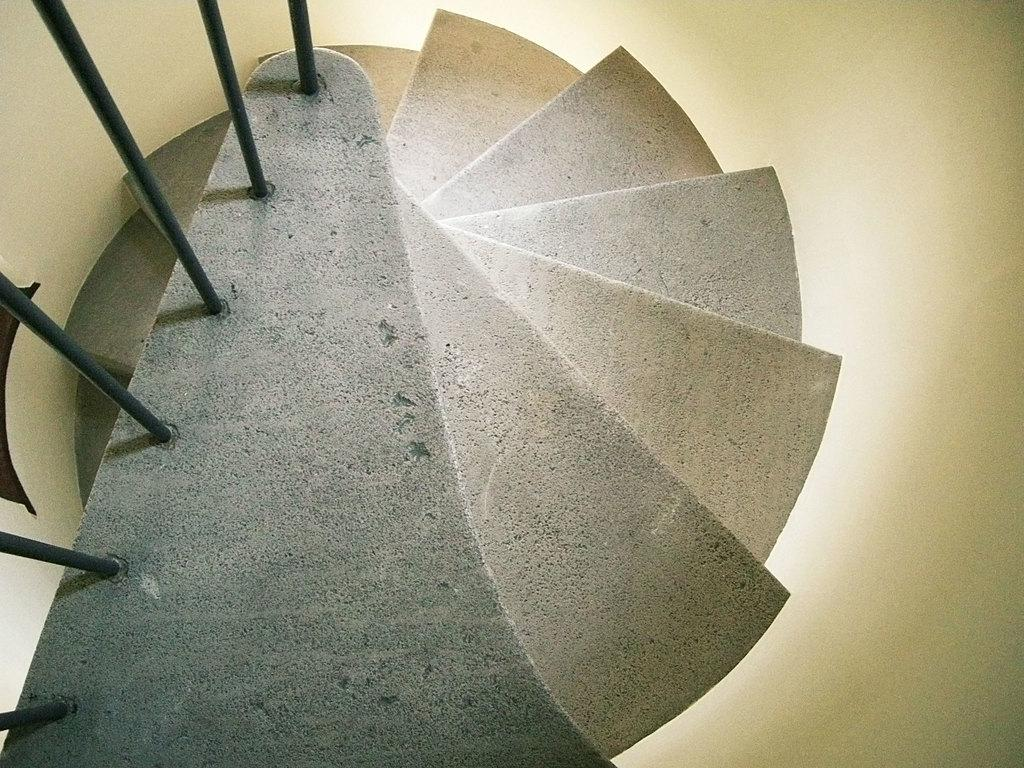What type of architectural feature is present in the image? There are steps in the image. Are there any other objects near the steps? Yes, there are iron rods near the steps in the image. How does the breath of the person affect the iron rods in the image? There is no person present in the image, and therefore no breath to affect the iron rods. 